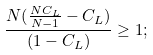Convert formula to latex. <formula><loc_0><loc_0><loc_500><loc_500>\frac { N ( \frac { N C _ { L } } { N - 1 } - C _ { L } ) } { ( 1 - C _ { L } ) } \geq 1 ;</formula> 